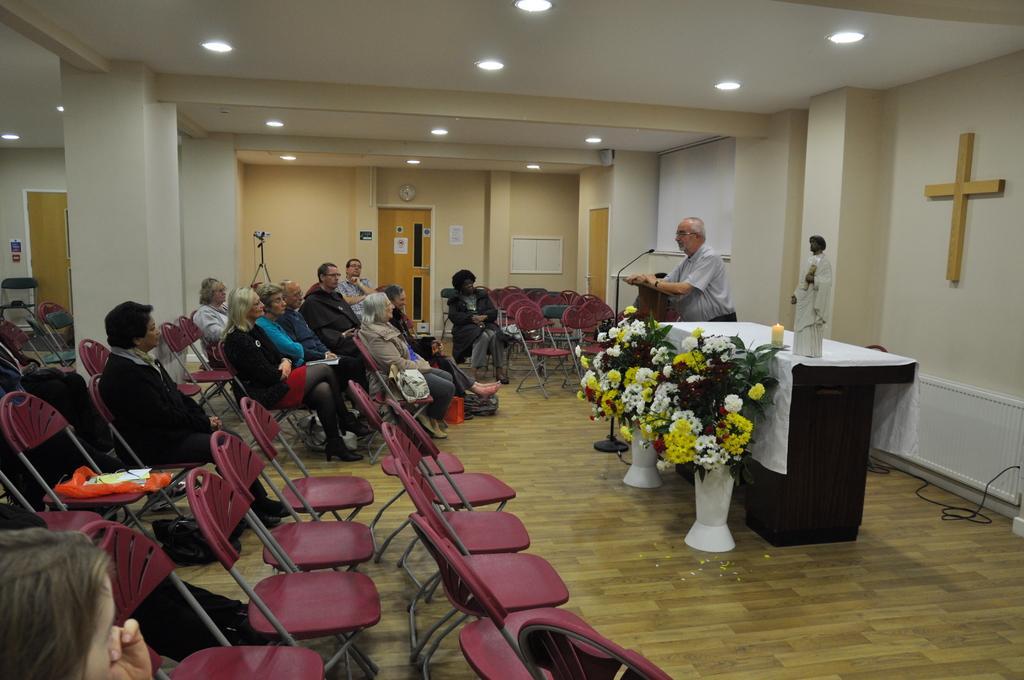Could you give a brief overview of what you see in this image? This is an inside view of a room. On the left side few people are sitting on the chairs facing towards the right side and there are few empty chairs. On the right side a man is standing and speaking on the mike. Beside him there is a table which is covered with a white cloth. On the table a sculpture of a person and a candle is placed. Beside the table there are few flower vases. In the background there are doors to the wall. On the left side, I can see the pillars. At the top of the image I can see the lights to the roof. 